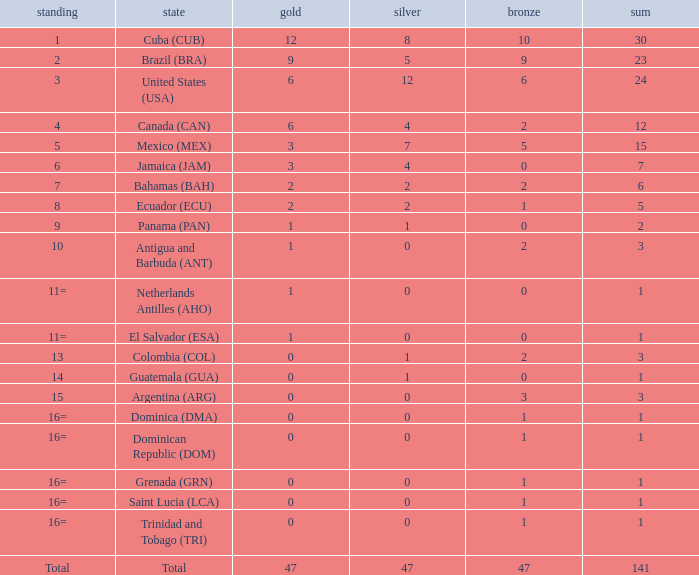What is the total gold with a total less than 1? None. 